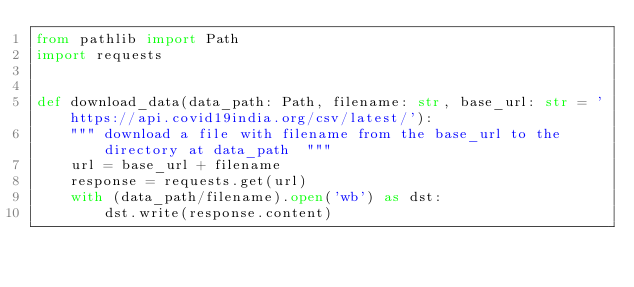Convert code to text. <code><loc_0><loc_0><loc_500><loc_500><_Python_>from pathlib import Path
import requests


def download_data(data_path: Path, filename: str, base_url: str = 'https://api.covid19india.org/csv/latest/'):
    """ download a file with filename from the base_url to the directory at data_path  """
    url = base_url + filename
    response = requests.get(url)
    with (data_path/filename).open('wb') as dst:
        dst.write(response.content)
</code> 